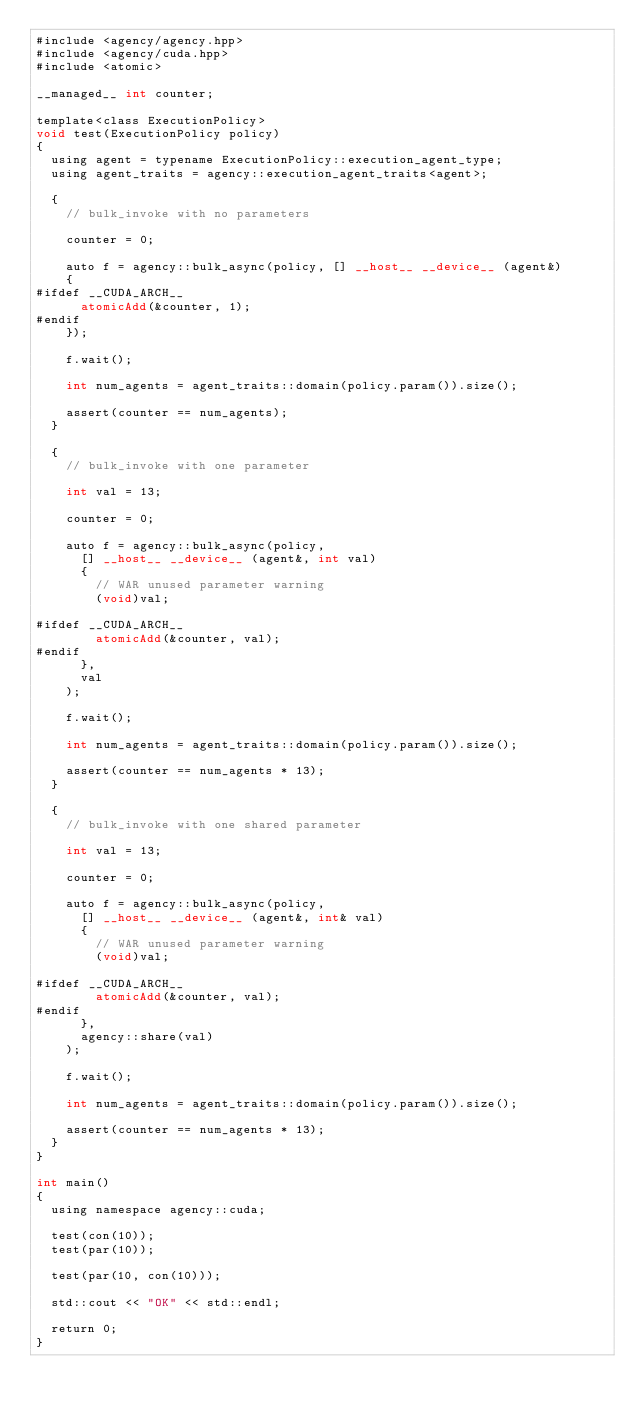Convert code to text. <code><loc_0><loc_0><loc_500><loc_500><_Cuda_>#include <agency/agency.hpp>
#include <agency/cuda.hpp>
#include <atomic>

__managed__ int counter;

template<class ExecutionPolicy>
void test(ExecutionPolicy policy)
{
  using agent = typename ExecutionPolicy::execution_agent_type;
  using agent_traits = agency::execution_agent_traits<agent>;

  {
    // bulk_invoke with no parameters

    counter = 0;

    auto f = agency::bulk_async(policy, [] __host__ __device__ (agent&)
    {
#ifdef __CUDA_ARCH__
      atomicAdd(&counter, 1);
#endif
    });

    f.wait();

    int num_agents = agent_traits::domain(policy.param()).size();

    assert(counter == num_agents);
  }

  {
    // bulk_invoke with one parameter

    int val = 13;

    counter = 0;

    auto f = agency::bulk_async(policy,
      [] __host__ __device__ (agent&, int val)
      {
        // WAR unused parameter warning
        (void)val;

#ifdef __CUDA_ARCH__
        atomicAdd(&counter, val);
#endif
      },
      val
    );

    f.wait();

    int num_agents = agent_traits::domain(policy.param()).size();

    assert(counter == num_agents * 13);
  }

  {
    // bulk_invoke with one shared parameter

    int val = 13;

    counter = 0;

    auto f = agency::bulk_async(policy,
      [] __host__ __device__ (agent&, int& val)
      {
        // WAR unused parameter warning
        (void)val;

#ifdef __CUDA_ARCH__
        atomicAdd(&counter, val);
#endif
      },
      agency::share(val)
    );

    f.wait();

    int num_agents = agent_traits::domain(policy.param()).size();

    assert(counter == num_agents * 13);
  }
}

int main()
{
  using namespace agency::cuda;

  test(con(10));
  test(par(10));

  test(par(10, con(10)));

  std::cout << "OK" << std::endl;

  return 0;
}

</code> 